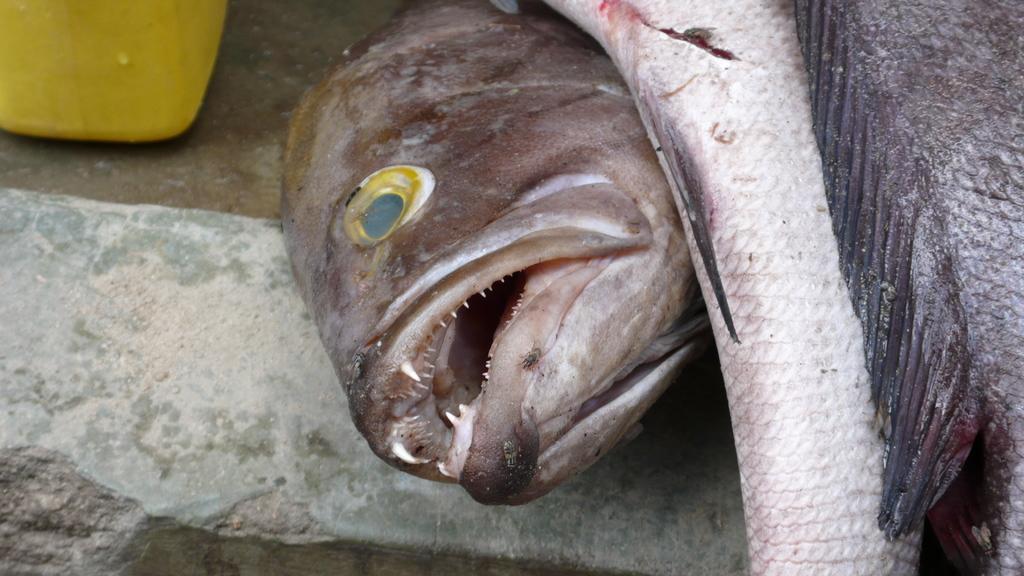Could you give a brief overview of what you see in this image? In this image there are fishes on the ground and a yellow color object. 